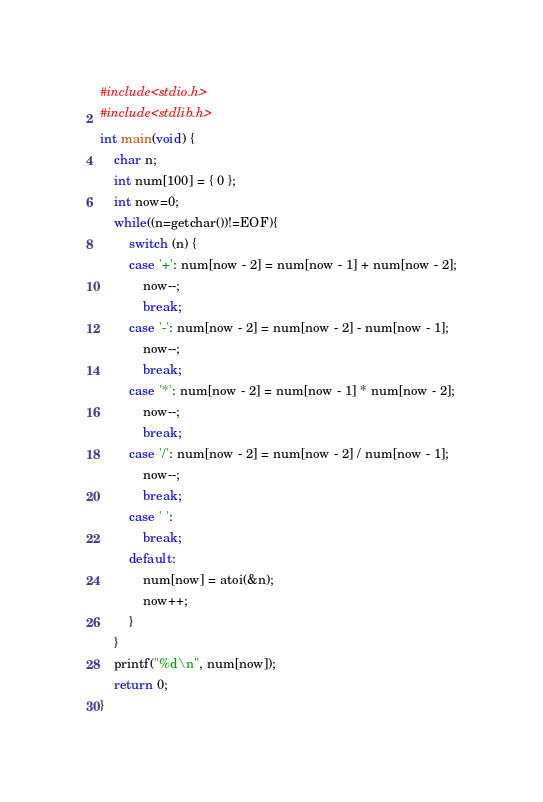Convert code to text. <code><loc_0><loc_0><loc_500><loc_500><_C_>#include<stdio.h>
#include<stdlib.h>
int main(void) {
	char n;
	int num[100] = { 0 };
	int now=0;
	while((n=getchar())!=EOF){
		switch (n) {
		case '+': num[now - 2] = num[now - 1] + num[now - 2];
			now--;
			break;
		case '-': num[now - 2] = num[now - 2] - num[now - 1];
			now--;
			break;
		case '*': num[now - 2] = num[now - 1] * num[now - 2];
			now--;
			break;
		case '/': num[now - 2] = num[now - 2] / num[now - 1];
			now--;
			break;
		case ' ':
			break;
		default:
			num[now] = atoi(&n);
			now++;
		}
	}
	printf("%d\n", num[now]);
	return 0;
}
</code> 